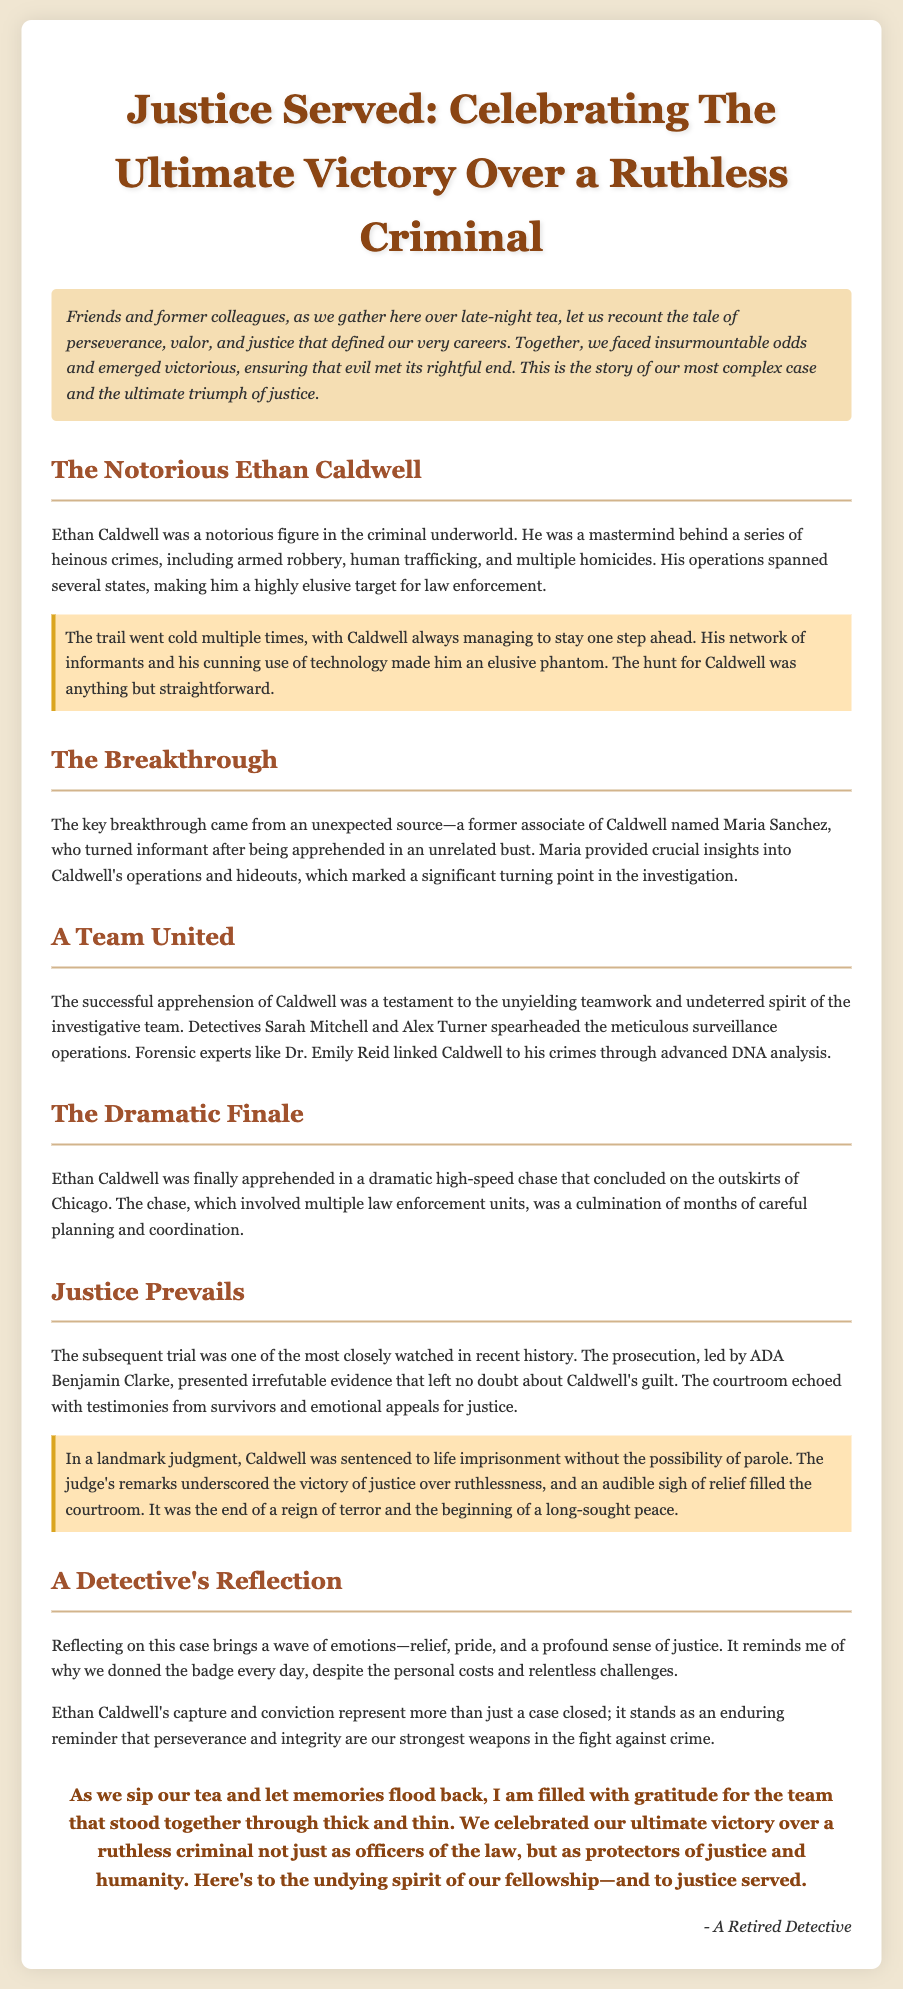What was Ethan Caldwell known for? Ethan Caldwell was known for being a notorious figure in the criminal underworld, involved in heinous crimes such as armed robbery, human trafficking, and multiple homicides.
Answer: heinous crimes Who provided crucial insights into Caldwell's operations? The crucial insights into Caldwell's operations came from Maria Sanchez, a former associate of Caldwell who turned informant.
Answer: Maria Sanchez What type of case was this eulogy celebrating? This eulogy celebrated the ultimate victory over a ruthless criminal.
Answer: victory over a ruthless criminal What was the outcome of Caldwell's trial? The outcome was that Caldwell was sentenced to life imprisonment without the possibility of parole.
Answer: life imprisonment Which city was the dramatic finale of Caldwell's apprehension located near? The dramatic finale of Caldwell's apprehension occurred on the outskirts of Chicago.
Answer: Chicago What emotions did the detective feel reflecting on the case? The detective felt relief, pride, and a profound sense of justice when reflecting on the case.
Answer: relief, pride, and a profound sense of justice What did the judge's remarks underscore in Caldwell's case? The judge's remarks underscored the victory of justice over ruthlessness.
Answer: victory of justice over ruthlessness What role did Detective Sarah Mitchell have in the case? Detective Sarah Mitchell spearheaded the meticulous surveillance operations related to the case.
Answer: spearheaded surveillance operations 